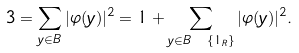Convert formula to latex. <formula><loc_0><loc_0><loc_500><loc_500>3 = \sum _ { y \in B } | \varphi ( y ) | ^ { 2 } = 1 + \sum _ { y \in B \ \{ 1 _ { R } \} } | \varphi ( y ) | ^ { 2 } .</formula> 